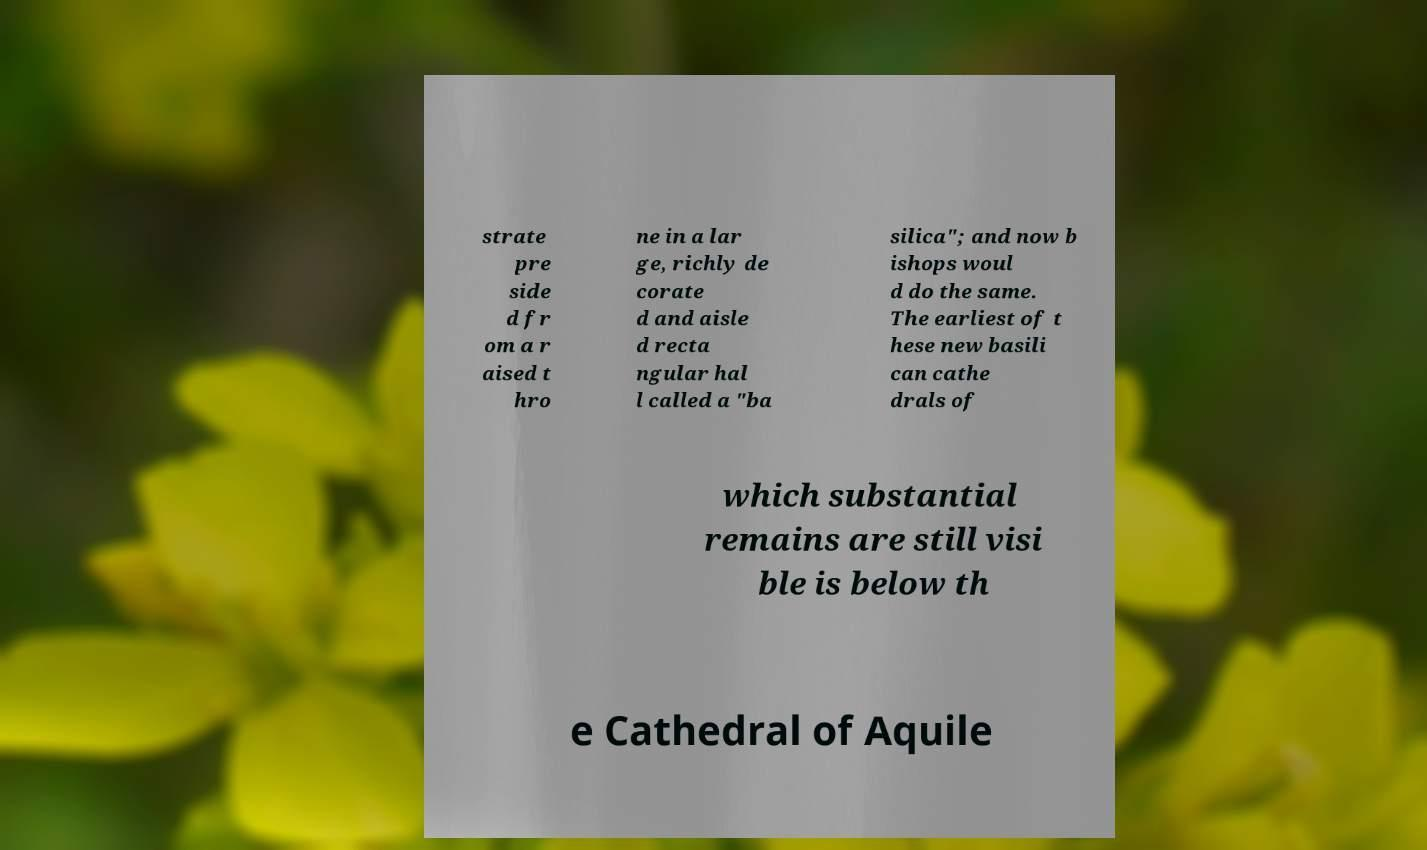I need the written content from this picture converted into text. Can you do that? strate pre side d fr om a r aised t hro ne in a lar ge, richly de corate d and aisle d recta ngular hal l called a "ba silica"; and now b ishops woul d do the same. The earliest of t hese new basili can cathe drals of which substantial remains are still visi ble is below th e Cathedral of Aquile 